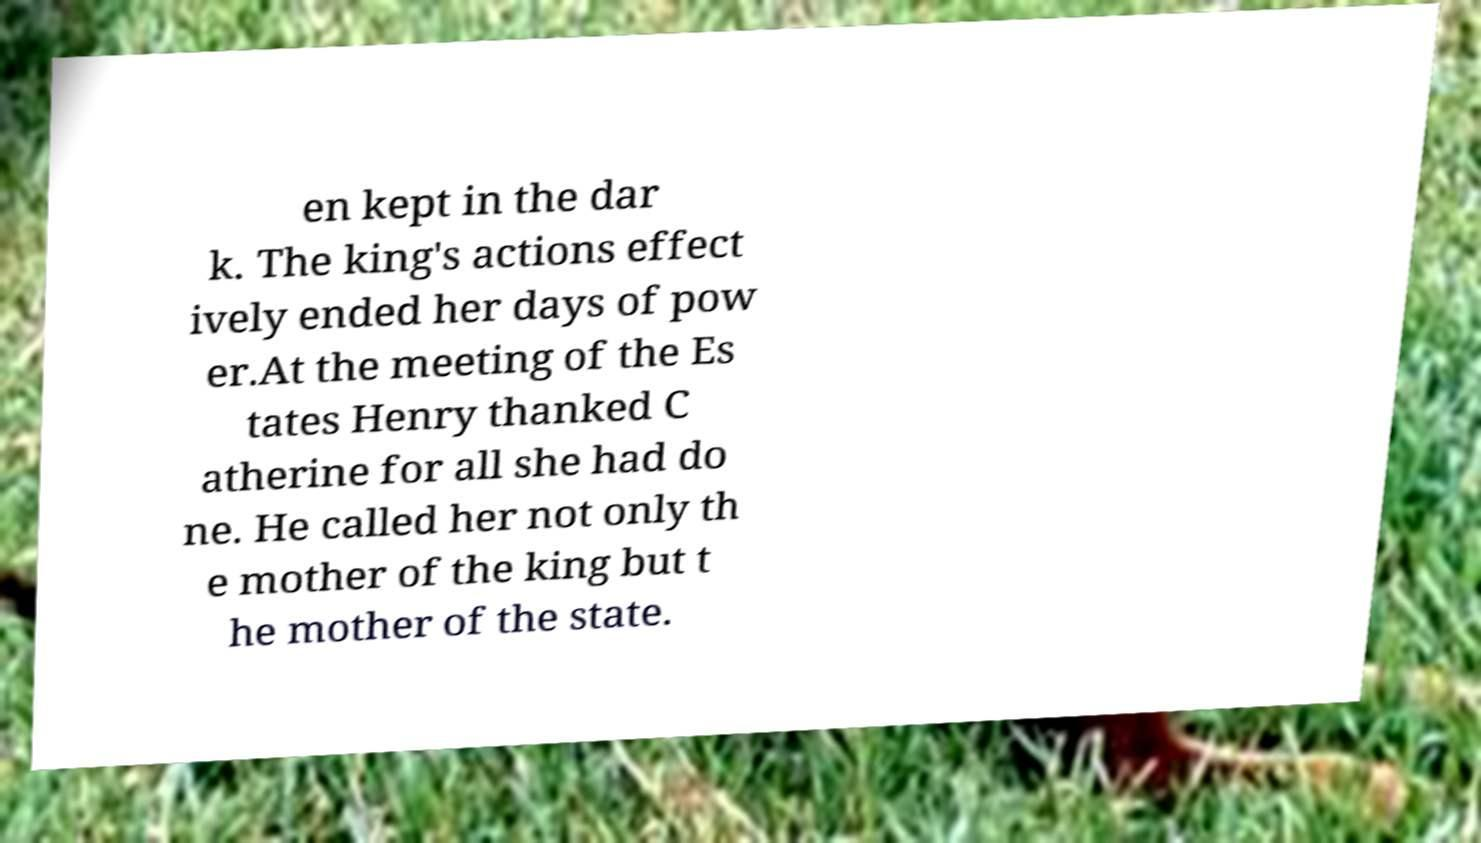Could you extract and type out the text from this image? en kept in the dar k. The king's actions effect ively ended her days of pow er.At the meeting of the Es tates Henry thanked C atherine for all she had do ne. He called her not only th e mother of the king but t he mother of the state. 